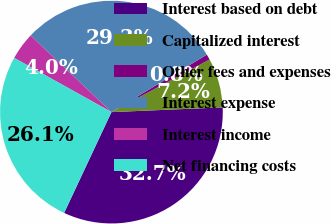<chart> <loc_0><loc_0><loc_500><loc_500><pie_chart><fcel>Interest based on debt<fcel>Capitalized interest<fcel>Other fees and expenses<fcel>Interest expense<fcel>Interest income<fcel>Net financing costs<nl><fcel>32.66%<fcel>7.16%<fcel>0.79%<fcel>29.3%<fcel>3.98%<fcel>26.11%<nl></chart> 